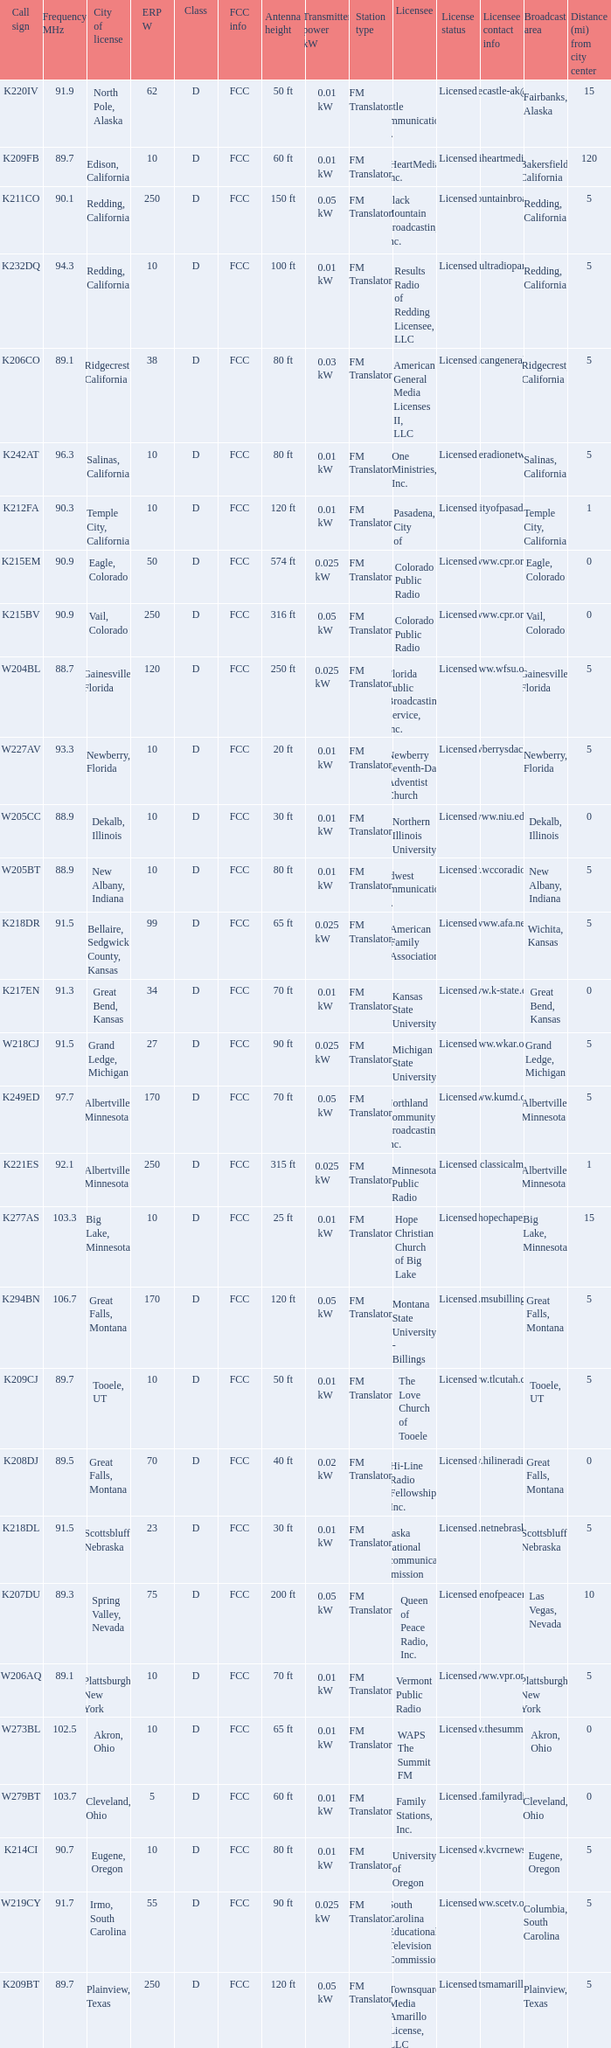Could you parse the entire table as a dict? {'header': ['Call sign', 'Frequency MHz', 'City of license', 'ERP W', 'Class', 'FCC info', 'Antenna height', 'Transmitter power kW', 'Station type', 'Licensee', 'License status', 'Licensee contact info', 'Broadcast area', 'Distance (mi) from city center'], 'rows': [['K220IV', '91.9', 'North Pole, Alaska', '62', 'D', 'FCC', '50 ft', '0.01 kW', 'FM Translator', 'Ice Castle Communications, Inc.', 'Licensed', 'www.icecastle-ak@tv.com', 'Fairbanks, Alaska', '15'], ['K209FB', '89.7', 'Edison, California', '10', 'D', 'FCC', '60 ft', '0.01 kW', 'FM Translator', 'iHeartMedia, Inc.', 'Licensed', 'www.iheartmedia.com', 'Bakersfield, California', '120'], ['K211CO', '90.1', 'Redding, California', '250', 'D', 'FCC', '150 ft', '0.05 kW', 'FM Translator', 'Black Mountain Broadcasting, Inc.', 'Licensed', 'www.blackmountainbroadcasting.com', 'Redding, California', '5'], ['K232DQ', '94.3', 'Redding, California', '10', 'D', 'FCC', '100 ft', '0.01 kW', 'FM Translator', 'Results Radio of Redding Licensee, LLC', 'Licensed', 'www.resultradioparters.com', 'Redding, California', '5'], ['K206CO', '89.1', 'Ridgecrest, California', '38', 'D', 'FCC', '80 ft', '0.03 kW', 'FM Translator', 'American General Media Licenses II, LLC', 'Licensed', 'www.americangeneralmedia.com', 'Ridgecrest, California', '5'], ['K242AT', '96.3', 'Salinas, California', '10', 'D', 'FCC', '80 ft', '0.01 kW', 'FM Translator', 'One Ministries, Inc.', 'Licensed', 'www.oneradionetwork.com', 'Salinas, California', '5'], ['K212FA', '90.3', 'Temple City, California', '10', 'D', 'FCC', '120 ft', '0.01 kW', 'FM Translator', 'Pasadena, City of', 'Licensed', 'www.cityofpasadena.net', 'Temple City, California', '1'], ['K215EM', '90.9', 'Eagle, Colorado', '50', 'D', 'FCC', '574 ft', '0.025 kW', 'FM Translator', 'Colorado Public Radio', 'Licensed', 'www.cpr.org', 'Eagle, Colorado', '0'], ['K215BV', '90.9', 'Vail, Colorado', '250', 'D', 'FCC', '316 ft', '0.05 kW', 'FM Translator', 'Colorado Public Radio', 'Licensed', 'www.cpr.org', 'Vail, Colorado', '0'], ['W204BL', '88.7', 'Gainesville, Florida', '120', 'D', 'FCC', '250 ft', '0.025 kW', 'FM Translator', 'Florida Public Broadcasting Service, Inc.', 'Licensed', 'www.wfsu.org', 'Gainesville, Florida', '5'], ['W227AV', '93.3', 'Newberry, Florida', '10', 'D', 'FCC', '20 ft', '0.01 kW', 'FM Translator', 'Newberry Seventh-Day Adventist Church', 'Licensed', 'www.newberrysdachurch.org', 'Newberry, Florida', '5'], ['W205CC', '88.9', 'Dekalb, Illinois', '10', 'D', 'FCC', '30 ft', '0.01 kW', 'FM Translator', 'Northern Illinois University', 'Licensed', 'www.niu.edu', 'Dekalb, Illinois', '0'], ['W205BT', '88.9', 'New Albany, Indiana', '10', 'D', 'FCC', '80 ft', '0.01 kW', 'FM Translator', 'Midwest Communications, Inc.', 'Licensed', 'www.wccoradio.com', 'New Albany, Indiana', '5'], ['K218DR', '91.5', 'Bellaire, Sedgwick County, Kansas', '99', 'D', 'FCC', '65 ft', '0.025 kW', 'FM Translator', 'American Family Association', 'Licensed', 'www.afa.net', 'Wichita, Kansas', '5'], ['K217EN', '91.3', 'Great Bend, Kansas', '34', 'D', 'FCC', '70 ft', '0.01 kW', 'FM Translator', 'Kansas State University', 'Licensed', 'www.k-state.edu', 'Great Bend, Kansas', '0'], ['W218CJ', '91.5', 'Grand Ledge, Michigan', '27', 'D', 'FCC', '90 ft', '0.025 kW', 'FM Translator', 'Michigan State University', 'Licensed', 'www.wkar.org', 'Grand Ledge, Michigan', '5'], ['K249ED', '97.7', 'Albertville, Minnesota', '170', 'D', 'FCC', '70 ft', '0.05 kW', 'FM Translator', 'Northland Community Broadcasting, Inc.', 'Licensed', 'www.kumd.org', 'Albertville, Minnesota', '5'], ['K221ES', '92.1', 'Albertville, Minnesota', '250', 'D', 'FCC', '315 ft', '0.025 kW', 'FM Translator', 'Minnesota Public Radio', 'Licensed', 'www.classicalmpr.org', 'Albertville, Minnesota', '1'], ['K277AS', '103.3', 'Big Lake, Minnesota', '10', 'D', 'FCC', '25 ft', '0.01 kW', 'FM Translator', 'Hope Christian Church of Big Lake', 'Licensed', 'www.hopechapelbl.org', 'Big Lake, Minnesota', '15'], ['K294BN', '106.7', 'Great Falls, Montana', '170', 'D', 'FCC', '120 ft', '0.05 kW', 'FM Translator', 'Montana State University - Billings', 'Licensed', 'www.msubillings.edu', 'Great Falls, Montana', '5'], ['K209CJ', '89.7', 'Tooele, UT', '10', 'D', 'FCC', '50 ft', '0.01 kW', 'FM Translator', 'The Love Church of Tooele', 'Licensed', 'www.tlcutah.com', 'Tooele, UT', '5'], ['K208DJ', '89.5', 'Great Falls, Montana', '70', 'D', 'FCC', '40 ft', '0.02 kW', 'FM Translator', 'Hi-Line Radio Fellowship, Inc.', 'Licensed', 'www.hilineradio.org', 'Great Falls, Montana', '0'], ['K218DL', '91.5', 'Scottsbluff, Nebraska', '23', 'D', 'FCC', '30 ft', '0.01 kW', 'FM Translator', 'Nebraska Educational Telecommunications Commission', 'Licensed', 'www.netnebraska.org', 'Scottsbluff, Nebraska', '5'], ['K207DU', '89.3', 'Spring Valley, Nevada', '75', 'D', 'FCC', '200 ft', '0.05 kW', 'FM Translator', 'Queen of Peace Radio, Inc.', 'Licensed', 'www.queenofpeaceradio.com', 'Las Vegas, Nevada', '10'], ['W206AQ', '89.1', 'Plattsburgh, New York', '10', 'D', 'FCC', '70 ft', '0.01 kW', 'FM Translator', 'Vermont Public Radio', 'Licensed', 'www.vpr.org', 'Plattsburgh, New York', '5'], ['W273BL', '102.5', 'Akron, Ohio', '10', 'D', 'FCC', '65 ft', '0.01 kW', 'FM Translator', 'WAPS The Summit FM', 'Licensed', 'www.thesummit.fm', 'Akron, Ohio', '0'], ['W279BT', '103.7', 'Cleveland, Ohio', '5', 'D', 'FCC', '60 ft', '0.01 kW', 'FM Translator', 'Family Stations, Inc.', 'Licensed', 'www.familyradio.org', 'Cleveland, Ohio', '0'], ['K214CI', '90.7', 'Eugene, Oregon', '10', 'D', 'FCC', '80 ft', '0.01 kW', 'FM Translator', 'University of Oregon', 'Licensed', 'www.kvcrnews.org', 'Eugene, Oregon', '5'], ['W219CY', '91.7', 'Irmo, South Carolina', '55', 'D', 'FCC', '90 ft', '0.025 kW', 'FM Translator', 'South Carolina Educational Television Commission', 'Licensed', 'www.scetv.org', 'Columbia, South Carolina', '5'], ['K209BT', '89.7', 'Plainview, Texas', '250', 'D', 'FCC', '120 ft', '0.05 kW', 'FM Translator', 'Townsquare Media Amarillo License, LLC', 'Licensed', 'www.tsmamarillo.com', 'Plainview, Texas', '5']]} What is the call sign of the translator in Spring Valley, Nevada? K207DU. 